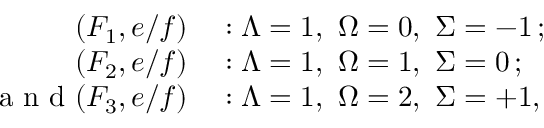Convert formula to latex. <formula><loc_0><loc_0><loc_500><loc_500>\begin{array} { r l } { ( F _ { 1 } , e / f ) } & \colon { \Lambda } = 1 , \ { \Omega } = 0 , \ { \Sigma } = - 1 \, ; } \\ { ( F _ { 2 } , e / f ) } & \colon { \Lambda } = 1 , \ { \Omega } = 1 , \ { \Sigma } = 0 \, ; } \\ { a n d ( F _ { 3 } , e / f ) } & \colon { \Lambda } = 1 , \ { \Omega } = 2 , \ { \Sigma } = + 1 , } \end{array}</formula> 